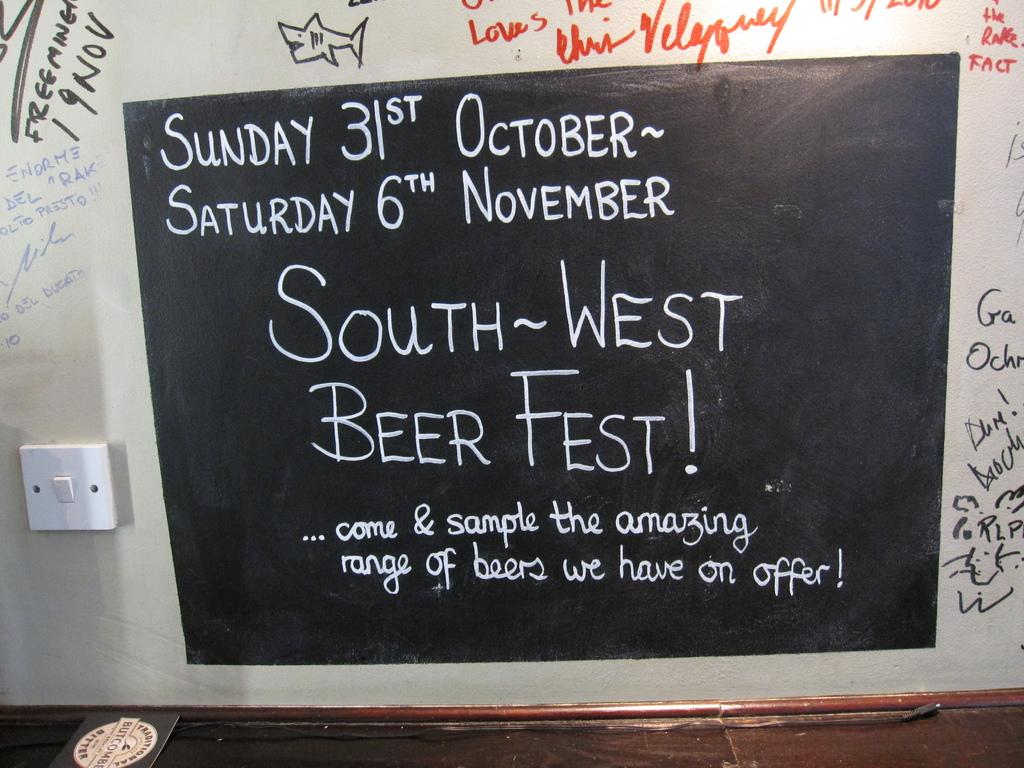<image>
Relay a brief, clear account of the picture shown. A black chalkboard displaying a message about a South West Beer Fest occurring from Sunday,October 31st to Saturday, November 6th. 